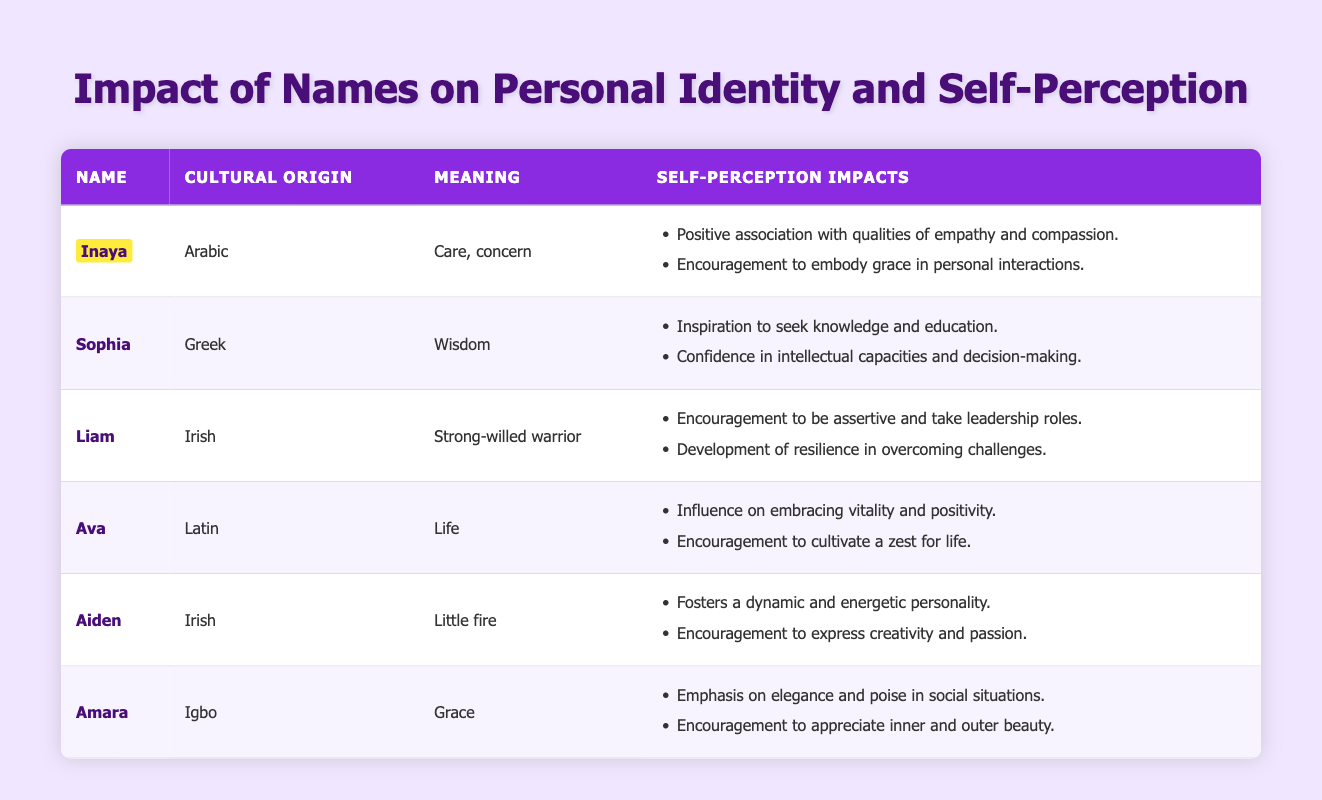What is the cultural origin of the name Inaya? The cultural origin of the name Inaya is listed in the table as Arabic.
Answer: Arabic Which name means "Life"? The table shows that the name that means "Life" is Ava.
Answer: Ava How many self-perception impacts are associated with the name Liam? The table indicates that there are two self-perception impacts for the name Liam, which are encouragement to be assertive and development of resilience.
Answer: 2 Are the meanings of the names Amara and Sophia connected to positive attributes? Yes, both names are associated with positive attributes; Amara means "Grace" and Sophia means "Wisdom".
Answer: Yes Which name, among these, encourages cultivating a zest for life? The name Ava is associated with the encouragement to cultivate a zest for life according to its listed self-perception impacts.
Answer: Ava What name, cultural origin, and meaning are associated with the encouragement for creativity and passion? The name Aiden is the one associated with "Little fire" (meaning) and the cultural origin is Irish, encouraging creativity and passion.
Answer: Aiden, Irish, Little fire If we consider the self-perception impacts for Inaya and Amara together, do they emphasize emotional attributes? Yes, both names focus on emotional attributes: Inaya emphasizes empathy, compassion, grace, while Amara emphasizes elegance, poise, and appreciation of beauty.
Answer: Yes What is the sum of the self-perception impacts for names that have Irish cultural origins? There are two names from Irish origin, Liam and Aiden, each with two self-perception impacts for a total of 4 (2 + 2).
Answer: 4 Which name has a self-perception impact that focuses on resilience? The name Liam has a self-perception impact that focuses on resilience, particularly in overcoming challenges.
Answer: Liam 